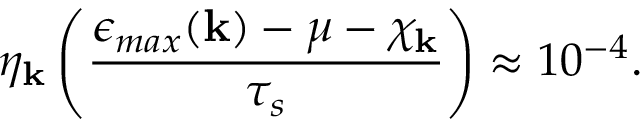Convert formula to latex. <formula><loc_0><loc_0><loc_500><loc_500>\eta _ { k } \left ( \frac { \epsilon _ { \max } ( { k } ) - \mu - \chi _ { k } } { \tau _ { s } } \right ) \approx 1 0 ^ { - 4 } .</formula> 